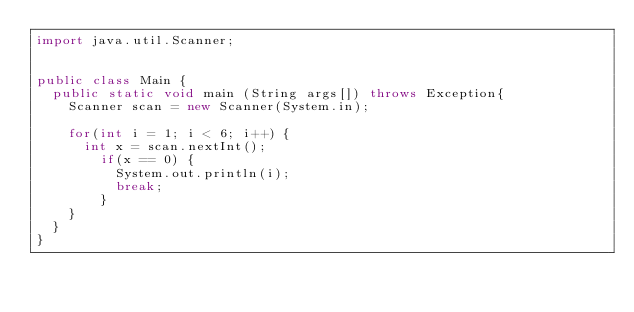Convert code to text. <code><loc_0><loc_0><loc_500><loc_500><_Java_>import java.util.Scanner;


public class Main {
	public static void main (String args[]) throws Exception{
		Scanner scan = new Scanner(System.in);

		for(int i = 1; i < 6; i++) {
			int x = scan.nextInt();
				if(x == 0) {
					System.out.println(i);
					break;
				}
		}
	}
}</code> 